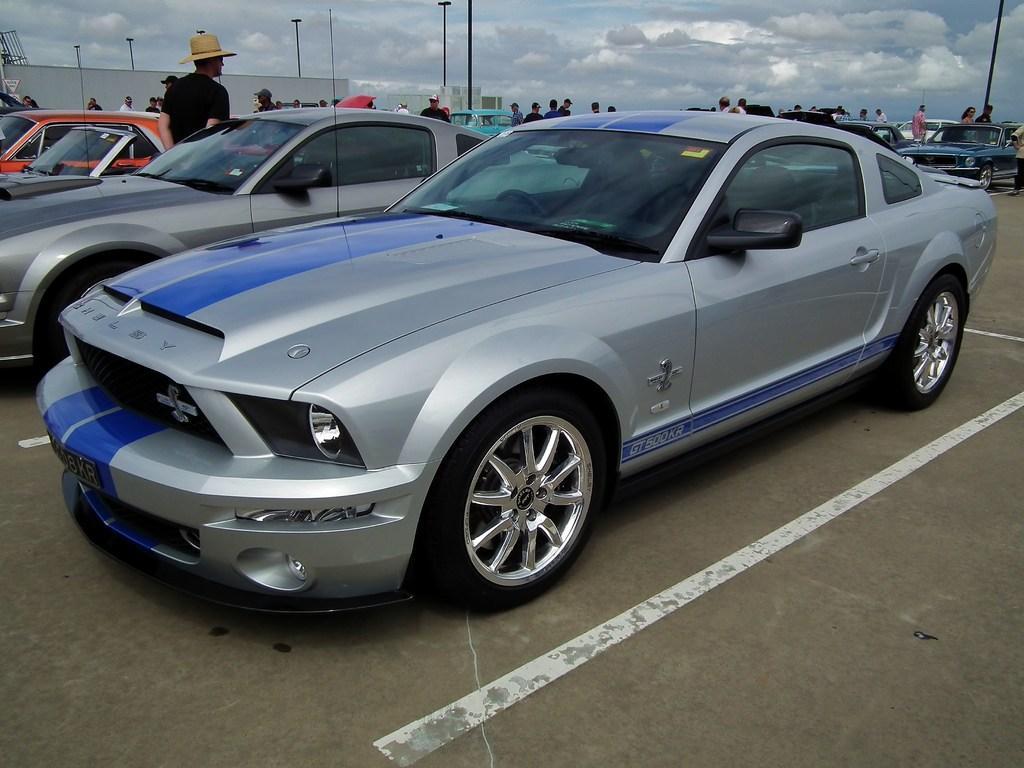In one or two sentences, can you explain what this image depicts? In this image in front there are cars on the road. There are people. There are poles. In the background of the image there are buildings and sky. 